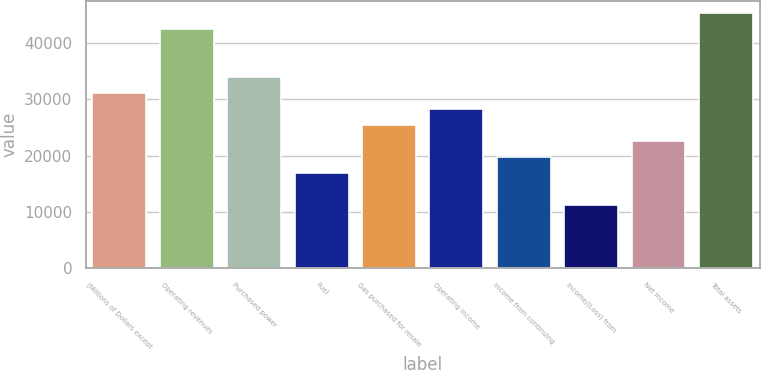Convert chart. <chart><loc_0><loc_0><loc_500><loc_500><bar_chart><fcel>(Millions of Dollars except<fcel>Operating revenues<fcel>Purchased power<fcel>Fuel<fcel>Gas purchased for resale<fcel>Operating income<fcel>Income from continuing<fcel>Income/(Loss) from<fcel>Net income<fcel>Total assets<nl><fcel>31088.2<fcel>42393<fcel>33914.4<fcel>16957.2<fcel>25435.8<fcel>28262<fcel>19783.4<fcel>11304.8<fcel>22609.6<fcel>45219.2<nl></chart> 